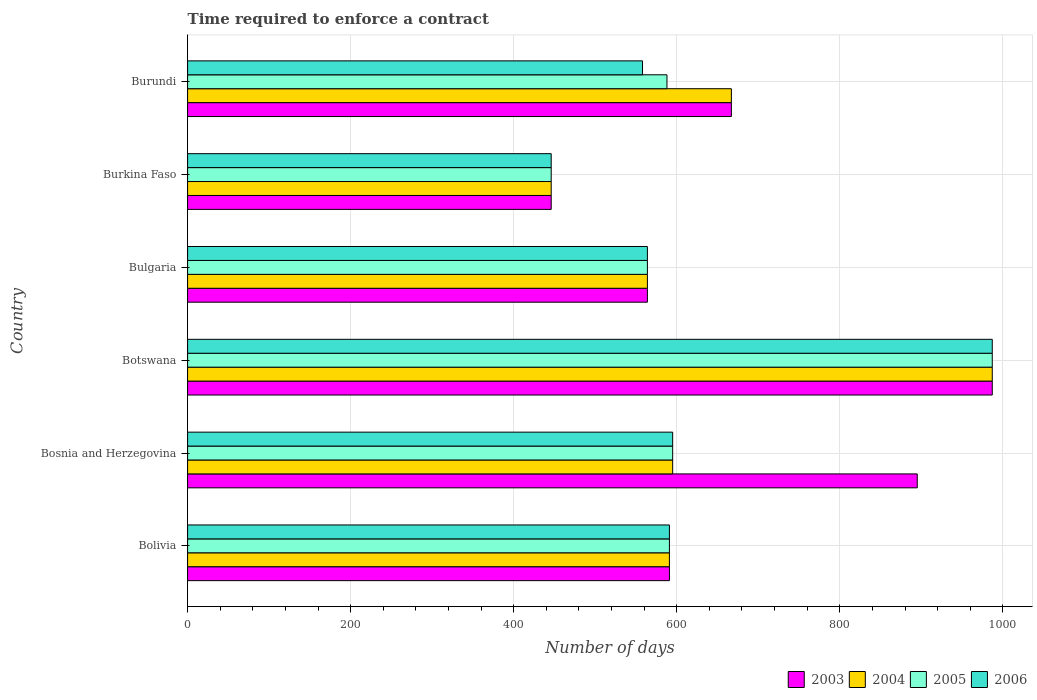How many different coloured bars are there?
Offer a terse response. 4. How many groups of bars are there?
Make the answer very short. 6. Are the number of bars per tick equal to the number of legend labels?
Offer a terse response. Yes. How many bars are there on the 4th tick from the top?
Make the answer very short. 4. How many bars are there on the 2nd tick from the bottom?
Your answer should be very brief. 4. What is the label of the 1st group of bars from the top?
Offer a very short reply. Burundi. What is the number of days required to enforce a contract in 2003 in Botswana?
Your answer should be very brief. 987. Across all countries, what is the maximum number of days required to enforce a contract in 2006?
Make the answer very short. 987. Across all countries, what is the minimum number of days required to enforce a contract in 2005?
Your answer should be very brief. 446. In which country was the number of days required to enforce a contract in 2003 maximum?
Your answer should be compact. Botswana. In which country was the number of days required to enforce a contract in 2004 minimum?
Your answer should be very brief. Burkina Faso. What is the total number of days required to enforce a contract in 2003 in the graph?
Provide a short and direct response. 4150. What is the difference between the number of days required to enforce a contract in 2003 in Bosnia and Herzegovina and that in Botswana?
Keep it short and to the point. -92. What is the difference between the number of days required to enforce a contract in 2006 in Botswana and the number of days required to enforce a contract in 2004 in Burkina Faso?
Your answer should be very brief. 541. What is the average number of days required to enforce a contract in 2006 per country?
Offer a very short reply. 623.5. What is the difference between the number of days required to enforce a contract in 2004 and number of days required to enforce a contract in 2003 in Bulgaria?
Provide a short and direct response. 0. What is the ratio of the number of days required to enforce a contract in 2003 in Botswana to that in Burundi?
Make the answer very short. 1.48. Is the difference between the number of days required to enforce a contract in 2004 in Bosnia and Herzegovina and Botswana greater than the difference between the number of days required to enforce a contract in 2003 in Bosnia and Herzegovina and Botswana?
Your response must be concise. No. What is the difference between the highest and the second highest number of days required to enforce a contract in 2003?
Keep it short and to the point. 92. What is the difference between the highest and the lowest number of days required to enforce a contract in 2004?
Your answer should be very brief. 541. Is it the case that in every country, the sum of the number of days required to enforce a contract in 2005 and number of days required to enforce a contract in 2003 is greater than the sum of number of days required to enforce a contract in 2006 and number of days required to enforce a contract in 2004?
Give a very brief answer. No. What does the 4th bar from the bottom in Bosnia and Herzegovina represents?
Offer a very short reply. 2006. How many bars are there?
Make the answer very short. 24. How many countries are there in the graph?
Keep it short and to the point. 6. Are the values on the major ticks of X-axis written in scientific E-notation?
Your answer should be compact. No. Does the graph contain any zero values?
Make the answer very short. No. How many legend labels are there?
Your response must be concise. 4. How are the legend labels stacked?
Your response must be concise. Horizontal. What is the title of the graph?
Provide a succinct answer. Time required to enforce a contract. Does "1993" appear as one of the legend labels in the graph?
Give a very brief answer. No. What is the label or title of the X-axis?
Provide a succinct answer. Number of days. What is the label or title of the Y-axis?
Make the answer very short. Country. What is the Number of days in 2003 in Bolivia?
Provide a short and direct response. 591. What is the Number of days in 2004 in Bolivia?
Your response must be concise. 591. What is the Number of days in 2005 in Bolivia?
Provide a succinct answer. 591. What is the Number of days in 2006 in Bolivia?
Give a very brief answer. 591. What is the Number of days in 2003 in Bosnia and Herzegovina?
Your response must be concise. 895. What is the Number of days in 2004 in Bosnia and Herzegovina?
Provide a succinct answer. 595. What is the Number of days in 2005 in Bosnia and Herzegovina?
Your response must be concise. 595. What is the Number of days of 2006 in Bosnia and Herzegovina?
Your answer should be very brief. 595. What is the Number of days in 2003 in Botswana?
Keep it short and to the point. 987. What is the Number of days in 2004 in Botswana?
Your answer should be compact. 987. What is the Number of days in 2005 in Botswana?
Offer a very short reply. 987. What is the Number of days in 2006 in Botswana?
Make the answer very short. 987. What is the Number of days of 2003 in Bulgaria?
Your answer should be very brief. 564. What is the Number of days of 2004 in Bulgaria?
Give a very brief answer. 564. What is the Number of days of 2005 in Bulgaria?
Give a very brief answer. 564. What is the Number of days of 2006 in Bulgaria?
Your answer should be very brief. 564. What is the Number of days in 2003 in Burkina Faso?
Give a very brief answer. 446. What is the Number of days in 2004 in Burkina Faso?
Your answer should be compact. 446. What is the Number of days in 2005 in Burkina Faso?
Provide a succinct answer. 446. What is the Number of days of 2006 in Burkina Faso?
Make the answer very short. 446. What is the Number of days in 2003 in Burundi?
Give a very brief answer. 667. What is the Number of days of 2004 in Burundi?
Your answer should be compact. 667. What is the Number of days in 2005 in Burundi?
Your response must be concise. 588. What is the Number of days of 2006 in Burundi?
Your answer should be compact. 558. Across all countries, what is the maximum Number of days of 2003?
Ensure brevity in your answer.  987. Across all countries, what is the maximum Number of days in 2004?
Provide a short and direct response. 987. Across all countries, what is the maximum Number of days of 2005?
Make the answer very short. 987. Across all countries, what is the maximum Number of days in 2006?
Give a very brief answer. 987. Across all countries, what is the minimum Number of days in 2003?
Your answer should be compact. 446. Across all countries, what is the minimum Number of days in 2004?
Your answer should be very brief. 446. Across all countries, what is the minimum Number of days of 2005?
Your response must be concise. 446. Across all countries, what is the minimum Number of days of 2006?
Provide a succinct answer. 446. What is the total Number of days of 2003 in the graph?
Give a very brief answer. 4150. What is the total Number of days of 2004 in the graph?
Keep it short and to the point. 3850. What is the total Number of days of 2005 in the graph?
Your response must be concise. 3771. What is the total Number of days in 2006 in the graph?
Make the answer very short. 3741. What is the difference between the Number of days of 2003 in Bolivia and that in Bosnia and Herzegovina?
Ensure brevity in your answer.  -304. What is the difference between the Number of days of 2005 in Bolivia and that in Bosnia and Herzegovina?
Your response must be concise. -4. What is the difference between the Number of days in 2006 in Bolivia and that in Bosnia and Herzegovina?
Offer a terse response. -4. What is the difference between the Number of days of 2003 in Bolivia and that in Botswana?
Offer a very short reply. -396. What is the difference between the Number of days of 2004 in Bolivia and that in Botswana?
Keep it short and to the point. -396. What is the difference between the Number of days in 2005 in Bolivia and that in Botswana?
Your response must be concise. -396. What is the difference between the Number of days in 2006 in Bolivia and that in Botswana?
Offer a very short reply. -396. What is the difference between the Number of days in 2003 in Bolivia and that in Bulgaria?
Your answer should be compact. 27. What is the difference between the Number of days of 2004 in Bolivia and that in Bulgaria?
Offer a very short reply. 27. What is the difference between the Number of days in 2005 in Bolivia and that in Bulgaria?
Offer a very short reply. 27. What is the difference between the Number of days in 2003 in Bolivia and that in Burkina Faso?
Make the answer very short. 145. What is the difference between the Number of days in 2004 in Bolivia and that in Burkina Faso?
Offer a very short reply. 145. What is the difference between the Number of days of 2005 in Bolivia and that in Burkina Faso?
Keep it short and to the point. 145. What is the difference between the Number of days of 2006 in Bolivia and that in Burkina Faso?
Offer a very short reply. 145. What is the difference between the Number of days in 2003 in Bolivia and that in Burundi?
Make the answer very short. -76. What is the difference between the Number of days in 2004 in Bolivia and that in Burundi?
Your answer should be very brief. -76. What is the difference between the Number of days of 2005 in Bolivia and that in Burundi?
Give a very brief answer. 3. What is the difference between the Number of days in 2006 in Bolivia and that in Burundi?
Provide a succinct answer. 33. What is the difference between the Number of days of 2003 in Bosnia and Herzegovina and that in Botswana?
Offer a very short reply. -92. What is the difference between the Number of days in 2004 in Bosnia and Herzegovina and that in Botswana?
Ensure brevity in your answer.  -392. What is the difference between the Number of days of 2005 in Bosnia and Herzegovina and that in Botswana?
Your answer should be compact. -392. What is the difference between the Number of days of 2006 in Bosnia and Herzegovina and that in Botswana?
Offer a very short reply. -392. What is the difference between the Number of days of 2003 in Bosnia and Herzegovina and that in Bulgaria?
Provide a succinct answer. 331. What is the difference between the Number of days of 2004 in Bosnia and Herzegovina and that in Bulgaria?
Your answer should be compact. 31. What is the difference between the Number of days in 2003 in Bosnia and Herzegovina and that in Burkina Faso?
Give a very brief answer. 449. What is the difference between the Number of days in 2004 in Bosnia and Herzegovina and that in Burkina Faso?
Your answer should be compact. 149. What is the difference between the Number of days in 2005 in Bosnia and Herzegovina and that in Burkina Faso?
Offer a very short reply. 149. What is the difference between the Number of days in 2006 in Bosnia and Herzegovina and that in Burkina Faso?
Offer a terse response. 149. What is the difference between the Number of days of 2003 in Bosnia and Herzegovina and that in Burundi?
Your answer should be very brief. 228. What is the difference between the Number of days of 2004 in Bosnia and Herzegovina and that in Burundi?
Provide a succinct answer. -72. What is the difference between the Number of days in 2005 in Bosnia and Herzegovina and that in Burundi?
Your response must be concise. 7. What is the difference between the Number of days in 2003 in Botswana and that in Bulgaria?
Your answer should be compact. 423. What is the difference between the Number of days of 2004 in Botswana and that in Bulgaria?
Give a very brief answer. 423. What is the difference between the Number of days in 2005 in Botswana and that in Bulgaria?
Offer a terse response. 423. What is the difference between the Number of days of 2006 in Botswana and that in Bulgaria?
Your answer should be compact. 423. What is the difference between the Number of days in 2003 in Botswana and that in Burkina Faso?
Offer a very short reply. 541. What is the difference between the Number of days in 2004 in Botswana and that in Burkina Faso?
Ensure brevity in your answer.  541. What is the difference between the Number of days of 2005 in Botswana and that in Burkina Faso?
Give a very brief answer. 541. What is the difference between the Number of days of 2006 in Botswana and that in Burkina Faso?
Offer a terse response. 541. What is the difference between the Number of days in 2003 in Botswana and that in Burundi?
Provide a short and direct response. 320. What is the difference between the Number of days of 2004 in Botswana and that in Burundi?
Provide a short and direct response. 320. What is the difference between the Number of days in 2005 in Botswana and that in Burundi?
Offer a very short reply. 399. What is the difference between the Number of days of 2006 in Botswana and that in Burundi?
Give a very brief answer. 429. What is the difference between the Number of days in 2003 in Bulgaria and that in Burkina Faso?
Provide a succinct answer. 118. What is the difference between the Number of days of 2004 in Bulgaria and that in Burkina Faso?
Offer a very short reply. 118. What is the difference between the Number of days in 2005 in Bulgaria and that in Burkina Faso?
Provide a short and direct response. 118. What is the difference between the Number of days in 2006 in Bulgaria and that in Burkina Faso?
Provide a succinct answer. 118. What is the difference between the Number of days in 2003 in Bulgaria and that in Burundi?
Make the answer very short. -103. What is the difference between the Number of days of 2004 in Bulgaria and that in Burundi?
Offer a terse response. -103. What is the difference between the Number of days in 2003 in Burkina Faso and that in Burundi?
Provide a short and direct response. -221. What is the difference between the Number of days in 2004 in Burkina Faso and that in Burundi?
Your answer should be very brief. -221. What is the difference between the Number of days in 2005 in Burkina Faso and that in Burundi?
Offer a terse response. -142. What is the difference between the Number of days of 2006 in Burkina Faso and that in Burundi?
Offer a very short reply. -112. What is the difference between the Number of days of 2003 in Bolivia and the Number of days of 2005 in Bosnia and Herzegovina?
Offer a terse response. -4. What is the difference between the Number of days in 2004 in Bolivia and the Number of days in 2005 in Bosnia and Herzegovina?
Offer a terse response. -4. What is the difference between the Number of days of 2005 in Bolivia and the Number of days of 2006 in Bosnia and Herzegovina?
Your response must be concise. -4. What is the difference between the Number of days in 2003 in Bolivia and the Number of days in 2004 in Botswana?
Give a very brief answer. -396. What is the difference between the Number of days of 2003 in Bolivia and the Number of days of 2005 in Botswana?
Your response must be concise. -396. What is the difference between the Number of days in 2003 in Bolivia and the Number of days in 2006 in Botswana?
Your answer should be very brief. -396. What is the difference between the Number of days of 2004 in Bolivia and the Number of days of 2005 in Botswana?
Provide a short and direct response. -396. What is the difference between the Number of days of 2004 in Bolivia and the Number of days of 2006 in Botswana?
Your answer should be compact. -396. What is the difference between the Number of days in 2005 in Bolivia and the Number of days in 2006 in Botswana?
Offer a very short reply. -396. What is the difference between the Number of days in 2003 in Bolivia and the Number of days in 2004 in Bulgaria?
Ensure brevity in your answer.  27. What is the difference between the Number of days of 2003 in Bolivia and the Number of days of 2005 in Bulgaria?
Keep it short and to the point. 27. What is the difference between the Number of days in 2003 in Bolivia and the Number of days in 2006 in Bulgaria?
Your answer should be compact. 27. What is the difference between the Number of days of 2004 in Bolivia and the Number of days of 2006 in Bulgaria?
Give a very brief answer. 27. What is the difference between the Number of days in 2003 in Bolivia and the Number of days in 2004 in Burkina Faso?
Provide a short and direct response. 145. What is the difference between the Number of days of 2003 in Bolivia and the Number of days of 2005 in Burkina Faso?
Ensure brevity in your answer.  145. What is the difference between the Number of days of 2003 in Bolivia and the Number of days of 2006 in Burkina Faso?
Offer a very short reply. 145. What is the difference between the Number of days in 2004 in Bolivia and the Number of days in 2005 in Burkina Faso?
Give a very brief answer. 145. What is the difference between the Number of days of 2004 in Bolivia and the Number of days of 2006 in Burkina Faso?
Your response must be concise. 145. What is the difference between the Number of days of 2005 in Bolivia and the Number of days of 2006 in Burkina Faso?
Give a very brief answer. 145. What is the difference between the Number of days in 2003 in Bolivia and the Number of days in 2004 in Burundi?
Keep it short and to the point. -76. What is the difference between the Number of days of 2003 in Bolivia and the Number of days of 2005 in Burundi?
Offer a terse response. 3. What is the difference between the Number of days in 2003 in Bolivia and the Number of days in 2006 in Burundi?
Your answer should be compact. 33. What is the difference between the Number of days in 2004 in Bolivia and the Number of days in 2005 in Burundi?
Ensure brevity in your answer.  3. What is the difference between the Number of days in 2004 in Bolivia and the Number of days in 2006 in Burundi?
Provide a succinct answer. 33. What is the difference between the Number of days in 2003 in Bosnia and Herzegovina and the Number of days in 2004 in Botswana?
Your answer should be very brief. -92. What is the difference between the Number of days of 2003 in Bosnia and Herzegovina and the Number of days of 2005 in Botswana?
Offer a terse response. -92. What is the difference between the Number of days in 2003 in Bosnia and Herzegovina and the Number of days in 2006 in Botswana?
Provide a short and direct response. -92. What is the difference between the Number of days in 2004 in Bosnia and Herzegovina and the Number of days in 2005 in Botswana?
Make the answer very short. -392. What is the difference between the Number of days in 2004 in Bosnia and Herzegovina and the Number of days in 2006 in Botswana?
Offer a very short reply. -392. What is the difference between the Number of days of 2005 in Bosnia and Herzegovina and the Number of days of 2006 in Botswana?
Make the answer very short. -392. What is the difference between the Number of days of 2003 in Bosnia and Herzegovina and the Number of days of 2004 in Bulgaria?
Offer a terse response. 331. What is the difference between the Number of days of 2003 in Bosnia and Herzegovina and the Number of days of 2005 in Bulgaria?
Give a very brief answer. 331. What is the difference between the Number of days in 2003 in Bosnia and Herzegovina and the Number of days in 2006 in Bulgaria?
Provide a short and direct response. 331. What is the difference between the Number of days of 2004 in Bosnia and Herzegovina and the Number of days of 2006 in Bulgaria?
Offer a very short reply. 31. What is the difference between the Number of days in 2003 in Bosnia and Herzegovina and the Number of days in 2004 in Burkina Faso?
Provide a succinct answer. 449. What is the difference between the Number of days in 2003 in Bosnia and Herzegovina and the Number of days in 2005 in Burkina Faso?
Offer a terse response. 449. What is the difference between the Number of days of 2003 in Bosnia and Herzegovina and the Number of days of 2006 in Burkina Faso?
Keep it short and to the point. 449. What is the difference between the Number of days of 2004 in Bosnia and Herzegovina and the Number of days of 2005 in Burkina Faso?
Your response must be concise. 149. What is the difference between the Number of days in 2004 in Bosnia and Herzegovina and the Number of days in 2006 in Burkina Faso?
Give a very brief answer. 149. What is the difference between the Number of days in 2005 in Bosnia and Herzegovina and the Number of days in 2006 in Burkina Faso?
Make the answer very short. 149. What is the difference between the Number of days in 2003 in Bosnia and Herzegovina and the Number of days in 2004 in Burundi?
Ensure brevity in your answer.  228. What is the difference between the Number of days of 2003 in Bosnia and Herzegovina and the Number of days of 2005 in Burundi?
Make the answer very short. 307. What is the difference between the Number of days of 2003 in Bosnia and Herzegovina and the Number of days of 2006 in Burundi?
Your answer should be very brief. 337. What is the difference between the Number of days of 2005 in Bosnia and Herzegovina and the Number of days of 2006 in Burundi?
Your answer should be very brief. 37. What is the difference between the Number of days of 2003 in Botswana and the Number of days of 2004 in Bulgaria?
Make the answer very short. 423. What is the difference between the Number of days in 2003 in Botswana and the Number of days in 2005 in Bulgaria?
Ensure brevity in your answer.  423. What is the difference between the Number of days of 2003 in Botswana and the Number of days of 2006 in Bulgaria?
Provide a short and direct response. 423. What is the difference between the Number of days in 2004 in Botswana and the Number of days in 2005 in Bulgaria?
Provide a short and direct response. 423. What is the difference between the Number of days in 2004 in Botswana and the Number of days in 2006 in Bulgaria?
Your answer should be very brief. 423. What is the difference between the Number of days in 2005 in Botswana and the Number of days in 2006 in Bulgaria?
Keep it short and to the point. 423. What is the difference between the Number of days in 2003 in Botswana and the Number of days in 2004 in Burkina Faso?
Your response must be concise. 541. What is the difference between the Number of days of 2003 in Botswana and the Number of days of 2005 in Burkina Faso?
Your response must be concise. 541. What is the difference between the Number of days of 2003 in Botswana and the Number of days of 2006 in Burkina Faso?
Ensure brevity in your answer.  541. What is the difference between the Number of days of 2004 in Botswana and the Number of days of 2005 in Burkina Faso?
Offer a very short reply. 541. What is the difference between the Number of days of 2004 in Botswana and the Number of days of 2006 in Burkina Faso?
Your answer should be very brief. 541. What is the difference between the Number of days of 2005 in Botswana and the Number of days of 2006 in Burkina Faso?
Offer a very short reply. 541. What is the difference between the Number of days in 2003 in Botswana and the Number of days in 2004 in Burundi?
Your answer should be compact. 320. What is the difference between the Number of days in 2003 in Botswana and the Number of days in 2005 in Burundi?
Make the answer very short. 399. What is the difference between the Number of days in 2003 in Botswana and the Number of days in 2006 in Burundi?
Your answer should be very brief. 429. What is the difference between the Number of days in 2004 in Botswana and the Number of days in 2005 in Burundi?
Keep it short and to the point. 399. What is the difference between the Number of days in 2004 in Botswana and the Number of days in 2006 in Burundi?
Keep it short and to the point. 429. What is the difference between the Number of days in 2005 in Botswana and the Number of days in 2006 in Burundi?
Your answer should be compact. 429. What is the difference between the Number of days in 2003 in Bulgaria and the Number of days in 2004 in Burkina Faso?
Offer a terse response. 118. What is the difference between the Number of days in 2003 in Bulgaria and the Number of days in 2005 in Burkina Faso?
Your answer should be compact. 118. What is the difference between the Number of days of 2003 in Bulgaria and the Number of days of 2006 in Burkina Faso?
Your response must be concise. 118. What is the difference between the Number of days of 2004 in Bulgaria and the Number of days of 2005 in Burkina Faso?
Keep it short and to the point. 118. What is the difference between the Number of days of 2004 in Bulgaria and the Number of days of 2006 in Burkina Faso?
Ensure brevity in your answer.  118. What is the difference between the Number of days in 2005 in Bulgaria and the Number of days in 2006 in Burkina Faso?
Give a very brief answer. 118. What is the difference between the Number of days of 2003 in Bulgaria and the Number of days of 2004 in Burundi?
Your response must be concise. -103. What is the difference between the Number of days of 2003 in Bulgaria and the Number of days of 2005 in Burundi?
Your answer should be compact. -24. What is the difference between the Number of days in 2003 in Bulgaria and the Number of days in 2006 in Burundi?
Ensure brevity in your answer.  6. What is the difference between the Number of days in 2003 in Burkina Faso and the Number of days in 2004 in Burundi?
Provide a succinct answer. -221. What is the difference between the Number of days in 2003 in Burkina Faso and the Number of days in 2005 in Burundi?
Provide a succinct answer. -142. What is the difference between the Number of days in 2003 in Burkina Faso and the Number of days in 2006 in Burundi?
Provide a succinct answer. -112. What is the difference between the Number of days of 2004 in Burkina Faso and the Number of days of 2005 in Burundi?
Offer a very short reply. -142. What is the difference between the Number of days in 2004 in Burkina Faso and the Number of days in 2006 in Burundi?
Make the answer very short. -112. What is the difference between the Number of days of 2005 in Burkina Faso and the Number of days of 2006 in Burundi?
Your response must be concise. -112. What is the average Number of days of 2003 per country?
Offer a very short reply. 691.67. What is the average Number of days in 2004 per country?
Your response must be concise. 641.67. What is the average Number of days of 2005 per country?
Make the answer very short. 628.5. What is the average Number of days in 2006 per country?
Give a very brief answer. 623.5. What is the difference between the Number of days in 2003 and Number of days in 2006 in Bolivia?
Your answer should be compact. 0. What is the difference between the Number of days in 2004 and Number of days in 2005 in Bolivia?
Keep it short and to the point. 0. What is the difference between the Number of days of 2004 and Number of days of 2006 in Bolivia?
Make the answer very short. 0. What is the difference between the Number of days of 2005 and Number of days of 2006 in Bolivia?
Offer a terse response. 0. What is the difference between the Number of days in 2003 and Number of days in 2004 in Bosnia and Herzegovina?
Offer a terse response. 300. What is the difference between the Number of days of 2003 and Number of days of 2005 in Bosnia and Herzegovina?
Your answer should be very brief. 300. What is the difference between the Number of days in 2003 and Number of days in 2006 in Bosnia and Herzegovina?
Keep it short and to the point. 300. What is the difference between the Number of days of 2004 and Number of days of 2005 in Bosnia and Herzegovina?
Provide a succinct answer. 0. What is the difference between the Number of days in 2004 and Number of days in 2006 in Bosnia and Herzegovina?
Make the answer very short. 0. What is the difference between the Number of days in 2003 and Number of days in 2006 in Botswana?
Your answer should be compact. 0. What is the difference between the Number of days of 2004 and Number of days of 2005 in Botswana?
Give a very brief answer. 0. What is the difference between the Number of days in 2003 and Number of days in 2006 in Bulgaria?
Offer a very short reply. 0. What is the difference between the Number of days in 2004 and Number of days in 2006 in Bulgaria?
Ensure brevity in your answer.  0. What is the difference between the Number of days of 2003 and Number of days of 2005 in Burkina Faso?
Provide a succinct answer. 0. What is the difference between the Number of days of 2004 and Number of days of 2006 in Burkina Faso?
Keep it short and to the point. 0. What is the difference between the Number of days of 2005 and Number of days of 2006 in Burkina Faso?
Offer a very short reply. 0. What is the difference between the Number of days of 2003 and Number of days of 2005 in Burundi?
Your answer should be compact. 79. What is the difference between the Number of days in 2003 and Number of days in 2006 in Burundi?
Provide a succinct answer. 109. What is the difference between the Number of days of 2004 and Number of days of 2005 in Burundi?
Make the answer very short. 79. What is the difference between the Number of days in 2004 and Number of days in 2006 in Burundi?
Provide a succinct answer. 109. What is the ratio of the Number of days of 2003 in Bolivia to that in Bosnia and Herzegovina?
Make the answer very short. 0.66. What is the ratio of the Number of days of 2005 in Bolivia to that in Bosnia and Herzegovina?
Keep it short and to the point. 0.99. What is the ratio of the Number of days of 2003 in Bolivia to that in Botswana?
Give a very brief answer. 0.6. What is the ratio of the Number of days in 2004 in Bolivia to that in Botswana?
Your answer should be compact. 0.6. What is the ratio of the Number of days in 2005 in Bolivia to that in Botswana?
Your answer should be compact. 0.6. What is the ratio of the Number of days of 2006 in Bolivia to that in Botswana?
Ensure brevity in your answer.  0.6. What is the ratio of the Number of days of 2003 in Bolivia to that in Bulgaria?
Your answer should be very brief. 1.05. What is the ratio of the Number of days in 2004 in Bolivia to that in Bulgaria?
Ensure brevity in your answer.  1.05. What is the ratio of the Number of days in 2005 in Bolivia to that in Bulgaria?
Your answer should be very brief. 1.05. What is the ratio of the Number of days of 2006 in Bolivia to that in Bulgaria?
Make the answer very short. 1.05. What is the ratio of the Number of days in 2003 in Bolivia to that in Burkina Faso?
Offer a terse response. 1.33. What is the ratio of the Number of days in 2004 in Bolivia to that in Burkina Faso?
Provide a short and direct response. 1.33. What is the ratio of the Number of days in 2005 in Bolivia to that in Burkina Faso?
Your answer should be compact. 1.33. What is the ratio of the Number of days in 2006 in Bolivia to that in Burkina Faso?
Offer a terse response. 1.33. What is the ratio of the Number of days of 2003 in Bolivia to that in Burundi?
Your answer should be very brief. 0.89. What is the ratio of the Number of days in 2004 in Bolivia to that in Burundi?
Ensure brevity in your answer.  0.89. What is the ratio of the Number of days in 2006 in Bolivia to that in Burundi?
Your response must be concise. 1.06. What is the ratio of the Number of days of 2003 in Bosnia and Herzegovina to that in Botswana?
Your response must be concise. 0.91. What is the ratio of the Number of days of 2004 in Bosnia and Herzegovina to that in Botswana?
Make the answer very short. 0.6. What is the ratio of the Number of days of 2005 in Bosnia and Herzegovina to that in Botswana?
Provide a short and direct response. 0.6. What is the ratio of the Number of days in 2006 in Bosnia and Herzegovina to that in Botswana?
Give a very brief answer. 0.6. What is the ratio of the Number of days of 2003 in Bosnia and Herzegovina to that in Bulgaria?
Give a very brief answer. 1.59. What is the ratio of the Number of days in 2004 in Bosnia and Herzegovina to that in Bulgaria?
Your response must be concise. 1.05. What is the ratio of the Number of days of 2005 in Bosnia and Herzegovina to that in Bulgaria?
Your response must be concise. 1.05. What is the ratio of the Number of days of 2006 in Bosnia and Herzegovina to that in Bulgaria?
Make the answer very short. 1.05. What is the ratio of the Number of days in 2003 in Bosnia and Herzegovina to that in Burkina Faso?
Your answer should be very brief. 2.01. What is the ratio of the Number of days of 2004 in Bosnia and Herzegovina to that in Burkina Faso?
Your response must be concise. 1.33. What is the ratio of the Number of days of 2005 in Bosnia and Herzegovina to that in Burkina Faso?
Provide a short and direct response. 1.33. What is the ratio of the Number of days of 2006 in Bosnia and Herzegovina to that in Burkina Faso?
Offer a terse response. 1.33. What is the ratio of the Number of days in 2003 in Bosnia and Herzegovina to that in Burundi?
Ensure brevity in your answer.  1.34. What is the ratio of the Number of days of 2004 in Bosnia and Herzegovina to that in Burundi?
Give a very brief answer. 0.89. What is the ratio of the Number of days in 2005 in Bosnia and Herzegovina to that in Burundi?
Your response must be concise. 1.01. What is the ratio of the Number of days of 2006 in Bosnia and Herzegovina to that in Burundi?
Your answer should be very brief. 1.07. What is the ratio of the Number of days of 2003 in Botswana to that in Bulgaria?
Your answer should be compact. 1.75. What is the ratio of the Number of days of 2006 in Botswana to that in Bulgaria?
Ensure brevity in your answer.  1.75. What is the ratio of the Number of days of 2003 in Botswana to that in Burkina Faso?
Offer a very short reply. 2.21. What is the ratio of the Number of days in 2004 in Botswana to that in Burkina Faso?
Give a very brief answer. 2.21. What is the ratio of the Number of days of 2005 in Botswana to that in Burkina Faso?
Ensure brevity in your answer.  2.21. What is the ratio of the Number of days in 2006 in Botswana to that in Burkina Faso?
Ensure brevity in your answer.  2.21. What is the ratio of the Number of days of 2003 in Botswana to that in Burundi?
Make the answer very short. 1.48. What is the ratio of the Number of days of 2004 in Botswana to that in Burundi?
Offer a very short reply. 1.48. What is the ratio of the Number of days of 2005 in Botswana to that in Burundi?
Make the answer very short. 1.68. What is the ratio of the Number of days in 2006 in Botswana to that in Burundi?
Ensure brevity in your answer.  1.77. What is the ratio of the Number of days of 2003 in Bulgaria to that in Burkina Faso?
Your answer should be compact. 1.26. What is the ratio of the Number of days of 2004 in Bulgaria to that in Burkina Faso?
Your answer should be compact. 1.26. What is the ratio of the Number of days in 2005 in Bulgaria to that in Burkina Faso?
Your answer should be compact. 1.26. What is the ratio of the Number of days of 2006 in Bulgaria to that in Burkina Faso?
Make the answer very short. 1.26. What is the ratio of the Number of days in 2003 in Bulgaria to that in Burundi?
Provide a short and direct response. 0.85. What is the ratio of the Number of days in 2004 in Bulgaria to that in Burundi?
Provide a short and direct response. 0.85. What is the ratio of the Number of days in 2005 in Bulgaria to that in Burundi?
Ensure brevity in your answer.  0.96. What is the ratio of the Number of days in 2006 in Bulgaria to that in Burundi?
Offer a very short reply. 1.01. What is the ratio of the Number of days of 2003 in Burkina Faso to that in Burundi?
Offer a very short reply. 0.67. What is the ratio of the Number of days in 2004 in Burkina Faso to that in Burundi?
Your answer should be very brief. 0.67. What is the ratio of the Number of days in 2005 in Burkina Faso to that in Burundi?
Give a very brief answer. 0.76. What is the ratio of the Number of days in 2006 in Burkina Faso to that in Burundi?
Your answer should be compact. 0.8. What is the difference between the highest and the second highest Number of days of 2003?
Your response must be concise. 92. What is the difference between the highest and the second highest Number of days in 2004?
Give a very brief answer. 320. What is the difference between the highest and the second highest Number of days of 2005?
Keep it short and to the point. 392. What is the difference between the highest and the second highest Number of days in 2006?
Your answer should be compact. 392. What is the difference between the highest and the lowest Number of days of 2003?
Provide a short and direct response. 541. What is the difference between the highest and the lowest Number of days of 2004?
Your response must be concise. 541. What is the difference between the highest and the lowest Number of days of 2005?
Provide a succinct answer. 541. What is the difference between the highest and the lowest Number of days in 2006?
Provide a short and direct response. 541. 